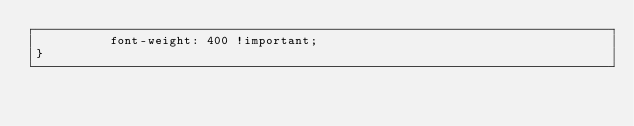<code> <loc_0><loc_0><loc_500><loc_500><_CSS_>          font-weight: 400 !important;
}</code> 